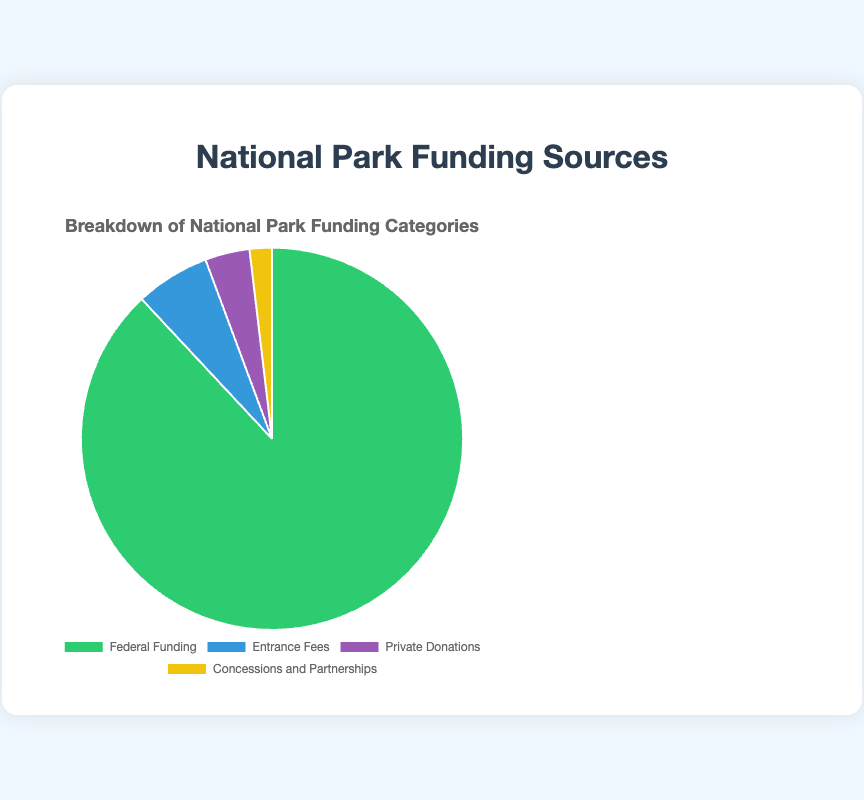What is the largest funding source for national parks? The largest portion on the pie chart is labeled "Federal Funding". This category is visually the largest, so Federal Funding is the primary source.
Answer: Federal Funding By how much is Federal Funding larger than Entrance Fees? Federal Funding amounts to $3.5 billion, while Entrance Fees amount to $250 million. To find the difference, subtract $250 million from $3.5 billion.
Answer: $3.25 billion What percentage of the total funding comes from Private Donations? The total funding is the sum of all categories: $3.5B + $0.25B + $0.15B + $0.075B = $3.975B. The percentage from Private Donations is then ($0.15B / $3.975B) * 100%.
Answer: 3.8% Which funding source has the smallest share and what is its amount? The smallest portion on the pie chart is labeled "Concessions and Partnerships", with the amount shown as $75 million.
Answer: Concessions and Partnerships, $75 million What is the combined amount of the two smallest funding categories? The smallest funding categories are "Private Donations" with $150 million and "Concessions and Partnerships" with $75 million. Adding these gives $150 million + $75 million.
Answer: $225 million What color represents the category of Entrance Fees in the pie chart? The segment for Entrance Fees is colored blue.
Answer: Blue How much more funding does Federal Funding provide compared to the sum of Private Donations and Concessions and Partnerships? Federal Funding provides $3.5 billion. The sum of Private Donations and Concessions and Partnerships is $150 million + $75 million = $225 million. The difference is $3.5 billion - $225 million.
Answer: $3.275 billion What is the approximate total amount of funding from all categories combined? Adding up all categories: $3.5B + $0.25B + $0.15B + $0.075B = $3.975 billion.
Answer: $3.975 billion Which color is used to represent the category with the second largest funding amount? The second largest funding category is "Entrance Fees", which is colored blue.
Answer: Blue Is the funding from Entrance Fees greater than the combined funding from Private Donations and Concessions and Partnerships? Entrance Fees provide $250 million, whereas the combined funding from Private Donations and Concessions and Partnerships is $150 million + $75 million = $225 million. $250 million is greater than $225 million.
Answer: Yes 